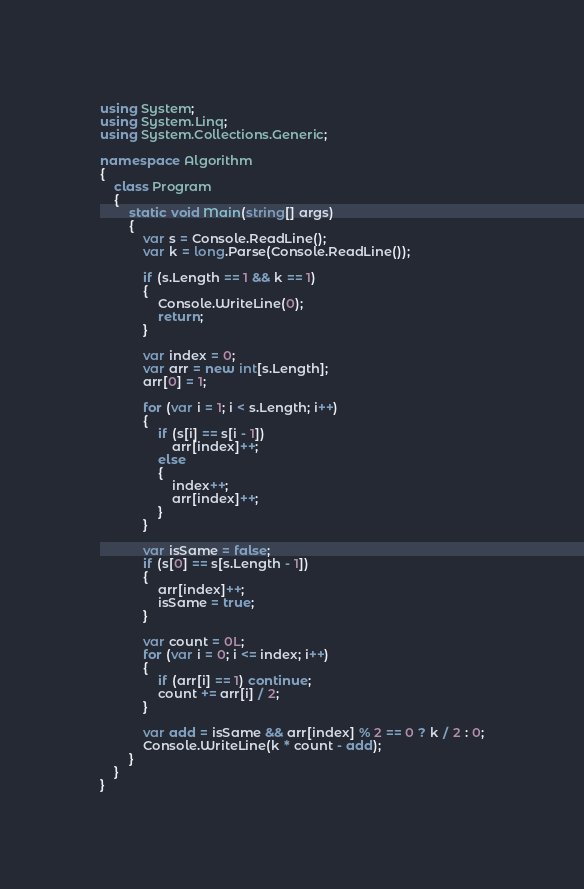Convert code to text. <code><loc_0><loc_0><loc_500><loc_500><_C#_>using System;
using System.Linq;
using System.Collections.Generic;

namespace Algorithm
{
    class Program
    {
        static void Main(string[] args)
        {
            var s = Console.ReadLine();
            var k = long.Parse(Console.ReadLine());

            if (s.Length == 1 && k == 1)
            {
                Console.WriteLine(0);
                return;
            }

            var index = 0;
            var arr = new int[s.Length];
            arr[0] = 1;
            
            for (var i = 1; i < s.Length; i++)
            {
                if (s[i] == s[i - 1])
                    arr[index]++;
                else
                {
                    index++;
                    arr[index]++;
                }
            }

            var isSame = false;
            if (s[0] == s[s.Length - 1])
            {
                arr[index]++;
                isSame = true;
            }

            var count = 0L;
            for (var i = 0; i <= index; i++)
            {
                if (arr[i] == 1) continue;
                count += arr[i] / 2;
            }

            var add = isSame && arr[index] % 2 == 0 ? k / 2 : 0;
            Console.WriteLine(k * count - add);
        }
    }
}
</code> 